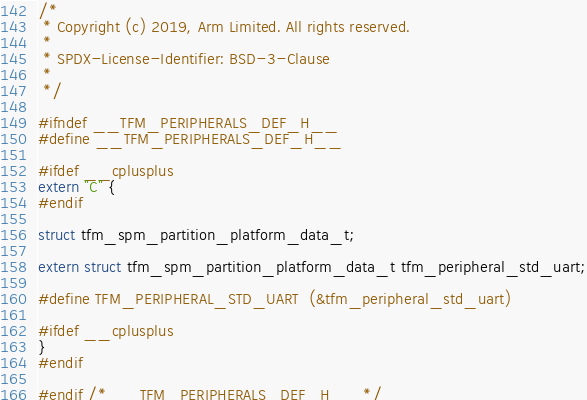Convert code to text. <code><loc_0><loc_0><loc_500><loc_500><_C_>/*
 * Copyright (c) 2019, Arm Limited. All rights reserved.
 *
 * SPDX-License-Identifier: BSD-3-Clause
 *
 */

#ifndef __TFM_PERIPHERALS_DEF_H__
#define __TFM_PERIPHERALS_DEF_H__

#ifdef __cplusplus
extern "C" {
#endif

struct tfm_spm_partition_platform_data_t;

extern struct tfm_spm_partition_platform_data_t tfm_peripheral_std_uart;

#define TFM_PERIPHERAL_STD_UART  (&tfm_peripheral_std_uart)

#ifdef __cplusplus
}
#endif

#endif /* __TFM_PERIPHERALS_DEF_H__ */
</code> 